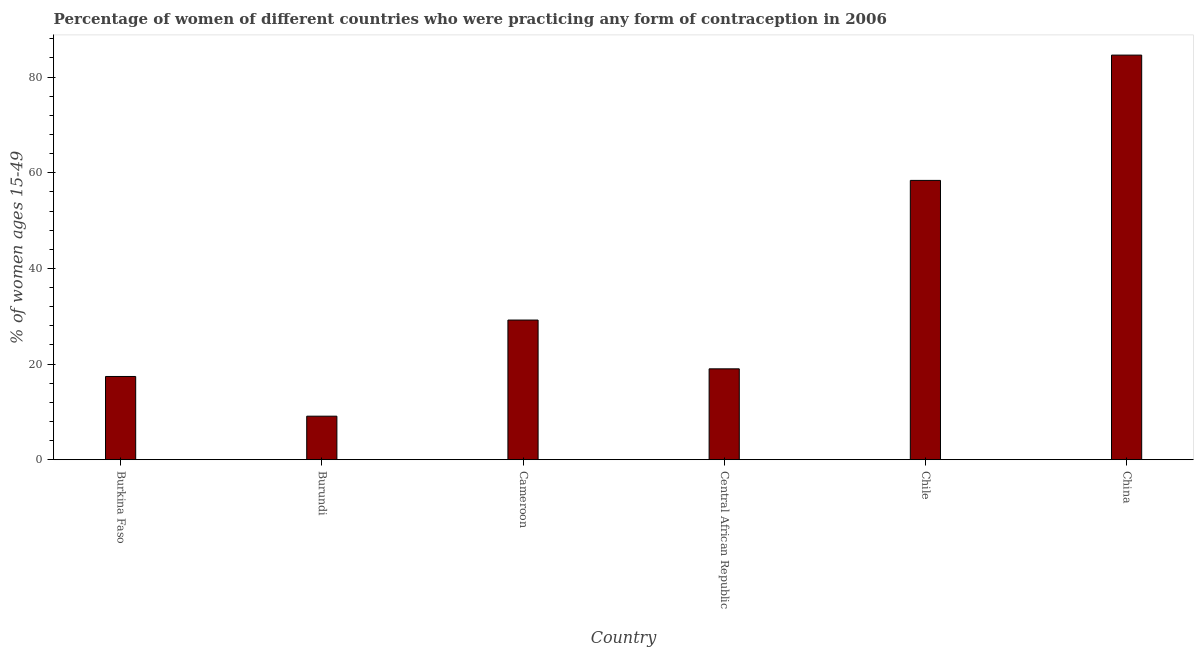Does the graph contain any zero values?
Offer a terse response. No. What is the title of the graph?
Make the answer very short. Percentage of women of different countries who were practicing any form of contraception in 2006. What is the label or title of the X-axis?
Make the answer very short. Country. What is the label or title of the Y-axis?
Keep it short and to the point. % of women ages 15-49. What is the contraceptive prevalence in China?
Offer a terse response. 84.6. Across all countries, what is the maximum contraceptive prevalence?
Your answer should be very brief. 84.6. Across all countries, what is the minimum contraceptive prevalence?
Your answer should be compact. 9.1. In which country was the contraceptive prevalence maximum?
Ensure brevity in your answer.  China. In which country was the contraceptive prevalence minimum?
Offer a very short reply. Burundi. What is the sum of the contraceptive prevalence?
Provide a short and direct response. 217.7. What is the difference between the contraceptive prevalence in Burundi and China?
Provide a short and direct response. -75.5. What is the average contraceptive prevalence per country?
Provide a short and direct response. 36.28. What is the median contraceptive prevalence?
Your answer should be compact. 24.1. In how many countries, is the contraceptive prevalence greater than 80 %?
Keep it short and to the point. 1. What is the ratio of the contraceptive prevalence in Central African Republic to that in China?
Your response must be concise. 0.23. Is the contraceptive prevalence in Burkina Faso less than that in Chile?
Provide a succinct answer. Yes. What is the difference between the highest and the second highest contraceptive prevalence?
Your answer should be very brief. 26.2. What is the difference between the highest and the lowest contraceptive prevalence?
Make the answer very short. 75.5. In how many countries, is the contraceptive prevalence greater than the average contraceptive prevalence taken over all countries?
Your answer should be compact. 2. How many bars are there?
Your answer should be very brief. 6. How many countries are there in the graph?
Your answer should be compact. 6. What is the difference between two consecutive major ticks on the Y-axis?
Make the answer very short. 20. What is the % of women ages 15-49 in Burundi?
Your response must be concise. 9.1. What is the % of women ages 15-49 in Cameroon?
Ensure brevity in your answer.  29.2. What is the % of women ages 15-49 in Central African Republic?
Provide a succinct answer. 19. What is the % of women ages 15-49 in Chile?
Offer a terse response. 58.4. What is the % of women ages 15-49 in China?
Your response must be concise. 84.6. What is the difference between the % of women ages 15-49 in Burkina Faso and Burundi?
Offer a terse response. 8.3. What is the difference between the % of women ages 15-49 in Burkina Faso and Cameroon?
Your answer should be compact. -11.8. What is the difference between the % of women ages 15-49 in Burkina Faso and Chile?
Ensure brevity in your answer.  -41. What is the difference between the % of women ages 15-49 in Burkina Faso and China?
Your answer should be compact. -67.2. What is the difference between the % of women ages 15-49 in Burundi and Cameroon?
Offer a very short reply. -20.1. What is the difference between the % of women ages 15-49 in Burundi and Central African Republic?
Provide a succinct answer. -9.9. What is the difference between the % of women ages 15-49 in Burundi and Chile?
Your answer should be very brief. -49.3. What is the difference between the % of women ages 15-49 in Burundi and China?
Offer a very short reply. -75.5. What is the difference between the % of women ages 15-49 in Cameroon and Chile?
Provide a succinct answer. -29.2. What is the difference between the % of women ages 15-49 in Cameroon and China?
Offer a terse response. -55.4. What is the difference between the % of women ages 15-49 in Central African Republic and Chile?
Your response must be concise. -39.4. What is the difference between the % of women ages 15-49 in Central African Republic and China?
Ensure brevity in your answer.  -65.6. What is the difference between the % of women ages 15-49 in Chile and China?
Your answer should be very brief. -26.2. What is the ratio of the % of women ages 15-49 in Burkina Faso to that in Burundi?
Offer a very short reply. 1.91. What is the ratio of the % of women ages 15-49 in Burkina Faso to that in Cameroon?
Keep it short and to the point. 0.6. What is the ratio of the % of women ages 15-49 in Burkina Faso to that in Central African Republic?
Keep it short and to the point. 0.92. What is the ratio of the % of women ages 15-49 in Burkina Faso to that in Chile?
Provide a succinct answer. 0.3. What is the ratio of the % of women ages 15-49 in Burkina Faso to that in China?
Your response must be concise. 0.21. What is the ratio of the % of women ages 15-49 in Burundi to that in Cameroon?
Offer a very short reply. 0.31. What is the ratio of the % of women ages 15-49 in Burundi to that in Central African Republic?
Ensure brevity in your answer.  0.48. What is the ratio of the % of women ages 15-49 in Burundi to that in Chile?
Provide a succinct answer. 0.16. What is the ratio of the % of women ages 15-49 in Burundi to that in China?
Make the answer very short. 0.11. What is the ratio of the % of women ages 15-49 in Cameroon to that in Central African Republic?
Your answer should be very brief. 1.54. What is the ratio of the % of women ages 15-49 in Cameroon to that in China?
Offer a very short reply. 0.34. What is the ratio of the % of women ages 15-49 in Central African Republic to that in Chile?
Your answer should be very brief. 0.33. What is the ratio of the % of women ages 15-49 in Central African Republic to that in China?
Provide a succinct answer. 0.23. What is the ratio of the % of women ages 15-49 in Chile to that in China?
Ensure brevity in your answer.  0.69. 